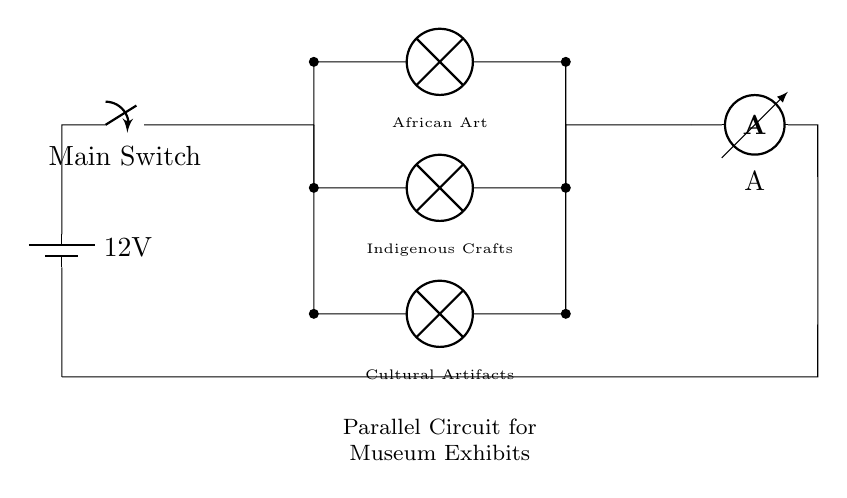What is the voltage supplied by the battery? The circuit shows a battery labeled with a voltage of 12V. Therefore, the voltage supplied is 12V.
Answer: 12V What type of circuit is this? The circuit consists of multiple branches where components are connected across the same two points, which defines it as a parallel circuit.
Answer: Parallel circuit What are the total number of lamps in the circuit? The diagram shows three lamps connected in parallel, namely African Art, Indigenous Crafts, and Cultural Artifacts. Counting them gives a total of three lamps.
Answer: Three lamps Which component is used to measure current in the circuit? The circuit contains an ammeter indicated by the symbol with the label A, which is specifically designed to measure current.
Answer: Ammeter What happens if one lamp fails? Since the circuit is parallel, the other lamps will continue to operate independently, as failure of one branch does not affect the others.
Answer: The other lamps remain operational What is the purpose of the main switch in the circuit? The main switch allows for the entire circuit to be turned on or off, controlling the power supply to all components simultaneously.
Answer: To control power supply How would you describe the connections between the components? The connections between the components are made in parallel, meaning each lamp has its own direct path to the voltage supply, ensuring equal voltage across all.
Answer: Parallel connections 